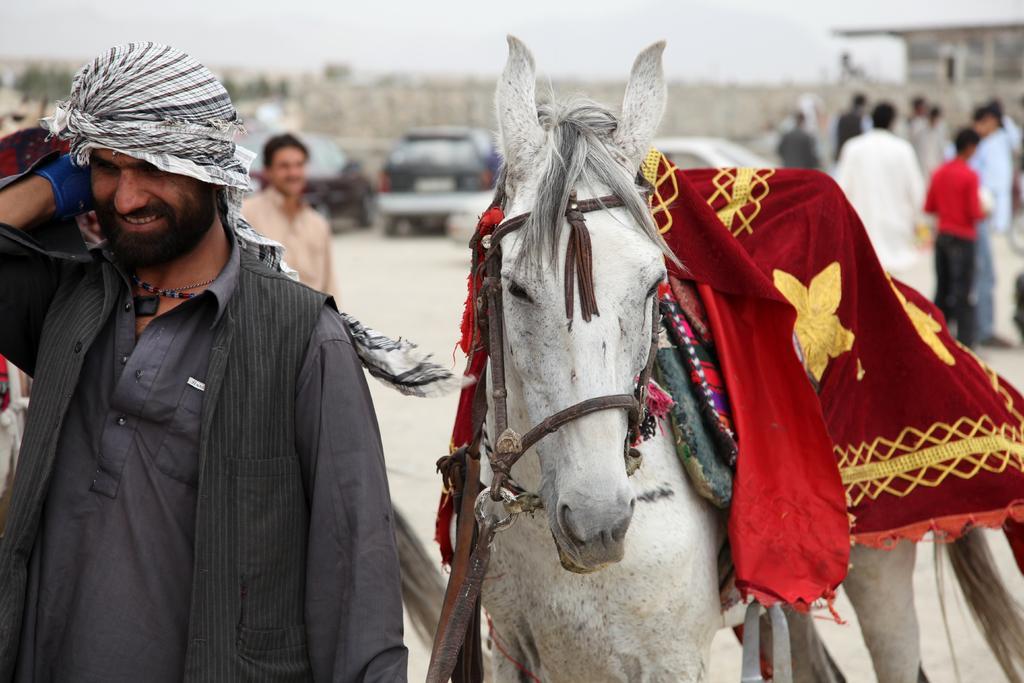Could you give a brief overview of what you see in this image? This picture is clicked on a road. There is a man standing to the left corner of the image and beside him there is a white horse. Behind him there are cars parked on the road. In the background there are few people standing, sky and trees. 